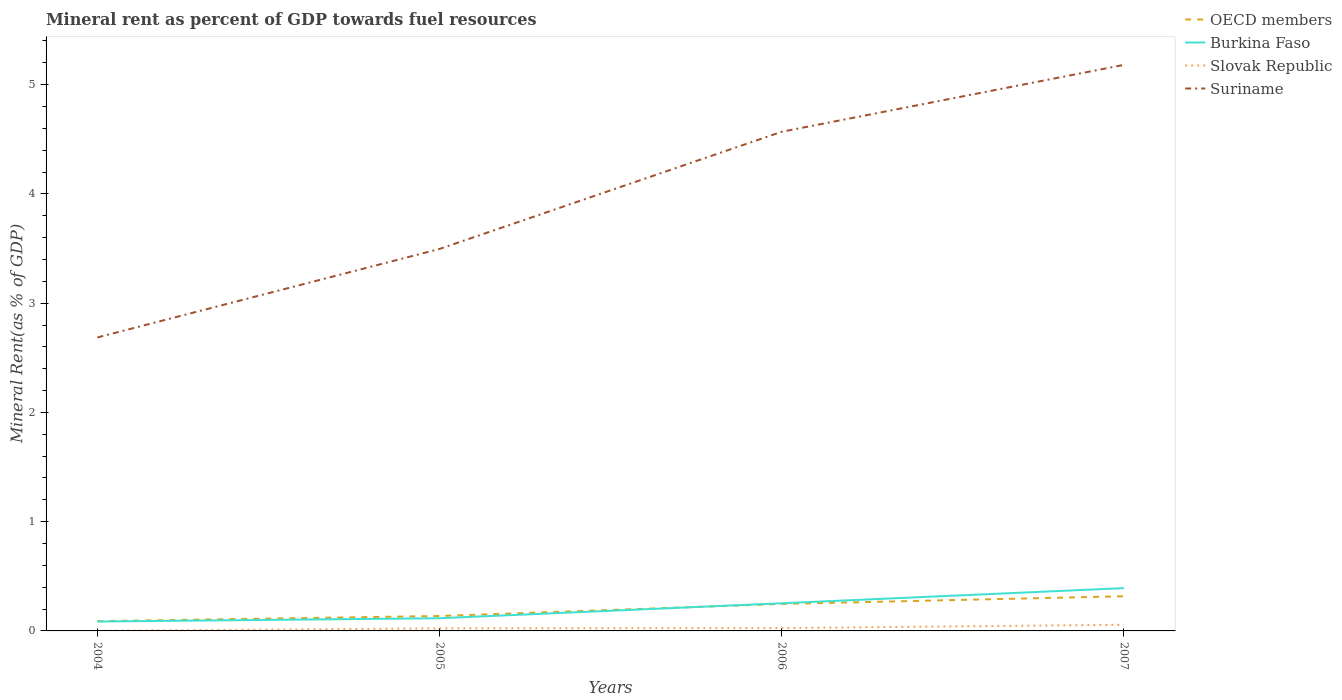Does the line corresponding to Burkina Faso intersect with the line corresponding to OECD members?
Your response must be concise. Yes. Across all years, what is the maximum mineral rent in Slovak Republic?
Your answer should be very brief. 0. What is the total mineral rent in Burkina Faso in the graph?
Make the answer very short. -0.28. What is the difference between the highest and the second highest mineral rent in Burkina Faso?
Provide a succinct answer. 0.31. What is the difference between the highest and the lowest mineral rent in OECD members?
Your response must be concise. 2. How many lines are there?
Ensure brevity in your answer.  4. What is the difference between two consecutive major ticks on the Y-axis?
Offer a terse response. 1. Are the values on the major ticks of Y-axis written in scientific E-notation?
Provide a succinct answer. No. What is the title of the graph?
Provide a succinct answer. Mineral rent as percent of GDP towards fuel resources. What is the label or title of the X-axis?
Make the answer very short. Years. What is the label or title of the Y-axis?
Offer a very short reply. Mineral Rent(as % of GDP). What is the Mineral Rent(as % of GDP) of OECD members in 2004?
Your answer should be very brief. 0.09. What is the Mineral Rent(as % of GDP) of Burkina Faso in 2004?
Ensure brevity in your answer.  0.09. What is the Mineral Rent(as % of GDP) in Slovak Republic in 2004?
Provide a succinct answer. 0. What is the Mineral Rent(as % of GDP) of Suriname in 2004?
Give a very brief answer. 2.69. What is the Mineral Rent(as % of GDP) in OECD members in 2005?
Offer a terse response. 0.14. What is the Mineral Rent(as % of GDP) in Burkina Faso in 2005?
Offer a terse response. 0.12. What is the Mineral Rent(as % of GDP) in Slovak Republic in 2005?
Offer a terse response. 0.02. What is the Mineral Rent(as % of GDP) of Suriname in 2005?
Provide a succinct answer. 3.5. What is the Mineral Rent(as % of GDP) of OECD members in 2006?
Give a very brief answer. 0.25. What is the Mineral Rent(as % of GDP) in Burkina Faso in 2006?
Provide a short and direct response. 0.25. What is the Mineral Rent(as % of GDP) of Slovak Republic in 2006?
Offer a very short reply. 0.03. What is the Mineral Rent(as % of GDP) of Suriname in 2006?
Your answer should be very brief. 4.57. What is the Mineral Rent(as % of GDP) in OECD members in 2007?
Give a very brief answer. 0.32. What is the Mineral Rent(as % of GDP) of Burkina Faso in 2007?
Your answer should be compact. 0.39. What is the Mineral Rent(as % of GDP) of Slovak Republic in 2007?
Make the answer very short. 0.06. What is the Mineral Rent(as % of GDP) of Suriname in 2007?
Your response must be concise. 5.18. Across all years, what is the maximum Mineral Rent(as % of GDP) of OECD members?
Provide a succinct answer. 0.32. Across all years, what is the maximum Mineral Rent(as % of GDP) in Burkina Faso?
Your answer should be compact. 0.39. Across all years, what is the maximum Mineral Rent(as % of GDP) of Slovak Republic?
Give a very brief answer. 0.06. Across all years, what is the maximum Mineral Rent(as % of GDP) in Suriname?
Keep it short and to the point. 5.18. Across all years, what is the minimum Mineral Rent(as % of GDP) of OECD members?
Offer a terse response. 0.09. Across all years, what is the minimum Mineral Rent(as % of GDP) in Burkina Faso?
Your response must be concise. 0.09. Across all years, what is the minimum Mineral Rent(as % of GDP) of Slovak Republic?
Give a very brief answer. 0. Across all years, what is the minimum Mineral Rent(as % of GDP) in Suriname?
Offer a terse response. 2.69. What is the total Mineral Rent(as % of GDP) of OECD members in the graph?
Make the answer very short. 0.79. What is the total Mineral Rent(as % of GDP) in Burkina Faso in the graph?
Provide a succinct answer. 0.85. What is the total Mineral Rent(as % of GDP) in Slovak Republic in the graph?
Keep it short and to the point. 0.11. What is the total Mineral Rent(as % of GDP) of Suriname in the graph?
Give a very brief answer. 15.93. What is the difference between the Mineral Rent(as % of GDP) of OECD members in 2004 and that in 2005?
Offer a very short reply. -0.05. What is the difference between the Mineral Rent(as % of GDP) in Burkina Faso in 2004 and that in 2005?
Your response must be concise. -0.03. What is the difference between the Mineral Rent(as % of GDP) in Slovak Republic in 2004 and that in 2005?
Provide a short and direct response. -0.02. What is the difference between the Mineral Rent(as % of GDP) of Suriname in 2004 and that in 2005?
Provide a short and direct response. -0.81. What is the difference between the Mineral Rent(as % of GDP) in OECD members in 2004 and that in 2006?
Provide a short and direct response. -0.16. What is the difference between the Mineral Rent(as % of GDP) of Burkina Faso in 2004 and that in 2006?
Your answer should be compact. -0.17. What is the difference between the Mineral Rent(as % of GDP) of Slovak Republic in 2004 and that in 2006?
Your response must be concise. -0.02. What is the difference between the Mineral Rent(as % of GDP) in Suriname in 2004 and that in 2006?
Give a very brief answer. -1.88. What is the difference between the Mineral Rent(as % of GDP) of OECD members in 2004 and that in 2007?
Your response must be concise. -0.23. What is the difference between the Mineral Rent(as % of GDP) of Burkina Faso in 2004 and that in 2007?
Provide a short and direct response. -0.31. What is the difference between the Mineral Rent(as % of GDP) in Slovak Republic in 2004 and that in 2007?
Your answer should be very brief. -0.06. What is the difference between the Mineral Rent(as % of GDP) in Suriname in 2004 and that in 2007?
Your response must be concise. -2.49. What is the difference between the Mineral Rent(as % of GDP) of OECD members in 2005 and that in 2006?
Provide a succinct answer. -0.11. What is the difference between the Mineral Rent(as % of GDP) in Burkina Faso in 2005 and that in 2006?
Offer a very short reply. -0.14. What is the difference between the Mineral Rent(as % of GDP) of Slovak Republic in 2005 and that in 2006?
Make the answer very short. -0. What is the difference between the Mineral Rent(as % of GDP) in Suriname in 2005 and that in 2006?
Your answer should be compact. -1.07. What is the difference between the Mineral Rent(as % of GDP) of OECD members in 2005 and that in 2007?
Make the answer very short. -0.18. What is the difference between the Mineral Rent(as % of GDP) of Burkina Faso in 2005 and that in 2007?
Your answer should be compact. -0.28. What is the difference between the Mineral Rent(as % of GDP) of Slovak Republic in 2005 and that in 2007?
Your answer should be very brief. -0.03. What is the difference between the Mineral Rent(as % of GDP) in Suriname in 2005 and that in 2007?
Make the answer very short. -1.69. What is the difference between the Mineral Rent(as % of GDP) in OECD members in 2006 and that in 2007?
Your answer should be compact. -0.07. What is the difference between the Mineral Rent(as % of GDP) in Burkina Faso in 2006 and that in 2007?
Your response must be concise. -0.14. What is the difference between the Mineral Rent(as % of GDP) of Slovak Republic in 2006 and that in 2007?
Provide a succinct answer. -0.03. What is the difference between the Mineral Rent(as % of GDP) in Suriname in 2006 and that in 2007?
Your answer should be very brief. -0.61. What is the difference between the Mineral Rent(as % of GDP) in OECD members in 2004 and the Mineral Rent(as % of GDP) in Burkina Faso in 2005?
Offer a very short reply. -0.03. What is the difference between the Mineral Rent(as % of GDP) in OECD members in 2004 and the Mineral Rent(as % of GDP) in Slovak Republic in 2005?
Ensure brevity in your answer.  0.07. What is the difference between the Mineral Rent(as % of GDP) in OECD members in 2004 and the Mineral Rent(as % of GDP) in Suriname in 2005?
Offer a very short reply. -3.41. What is the difference between the Mineral Rent(as % of GDP) of Burkina Faso in 2004 and the Mineral Rent(as % of GDP) of Slovak Republic in 2005?
Your answer should be compact. 0.06. What is the difference between the Mineral Rent(as % of GDP) in Burkina Faso in 2004 and the Mineral Rent(as % of GDP) in Suriname in 2005?
Provide a short and direct response. -3.41. What is the difference between the Mineral Rent(as % of GDP) of Slovak Republic in 2004 and the Mineral Rent(as % of GDP) of Suriname in 2005?
Your response must be concise. -3.49. What is the difference between the Mineral Rent(as % of GDP) of OECD members in 2004 and the Mineral Rent(as % of GDP) of Burkina Faso in 2006?
Your answer should be compact. -0.16. What is the difference between the Mineral Rent(as % of GDP) in OECD members in 2004 and the Mineral Rent(as % of GDP) in Slovak Republic in 2006?
Offer a terse response. 0.06. What is the difference between the Mineral Rent(as % of GDP) of OECD members in 2004 and the Mineral Rent(as % of GDP) of Suriname in 2006?
Your answer should be very brief. -4.48. What is the difference between the Mineral Rent(as % of GDP) in Burkina Faso in 2004 and the Mineral Rent(as % of GDP) in Slovak Republic in 2006?
Offer a terse response. 0.06. What is the difference between the Mineral Rent(as % of GDP) of Burkina Faso in 2004 and the Mineral Rent(as % of GDP) of Suriname in 2006?
Your answer should be very brief. -4.48. What is the difference between the Mineral Rent(as % of GDP) of Slovak Republic in 2004 and the Mineral Rent(as % of GDP) of Suriname in 2006?
Offer a very short reply. -4.57. What is the difference between the Mineral Rent(as % of GDP) of OECD members in 2004 and the Mineral Rent(as % of GDP) of Burkina Faso in 2007?
Your answer should be very brief. -0.3. What is the difference between the Mineral Rent(as % of GDP) in OECD members in 2004 and the Mineral Rent(as % of GDP) in Slovak Republic in 2007?
Your answer should be very brief. 0.03. What is the difference between the Mineral Rent(as % of GDP) in OECD members in 2004 and the Mineral Rent(as % of GDP) in Suriname in 2007?
Give a very brief answer. -5.09. What is the difference between the Mineral Rent(as % of GDP) of Burkina Faso in 2004 and the Mineral Rent(as % of GDP) of Slovak Republic in 2007?
Ensure brevity in your answer.  0.03. What is the difference between the Mineral Rent(as % of GDP) of Burkina Faso in 2004 and the Mineral Rent(as % of GDP) of Suriname in 2007?
Provide a succinct answer. -5.1. What is the difference between the Mineral Rent(as % of GDP) in Slovak Republic in 2004 and the Mineral Rent(as % of GDP) in Suriname in 2007?
Offer a very short reply. -5.18. What is the difference between the Mineral Rent(as % of GDP) in OECD members in 2005 and the Mineral Rent(as % of GDP) in Burkina Faso in 2006?
Your answer should be very brief. -0.12. What is the difference between the Mineral Rent(as % of GDP) of OECD members in 2005 and the Mineral Rent(as % of GDP) of Slovak Republic in 2006?
Provide a short and direct response. 0.11. What is the difference between the Mineral Rent(as % of GDP) in OECD members in 2005 and the Mineral Rent(as % of GDP) in Suriname in 2006?
Keep it short and to the point. -4.43. What is the difference between the Mineral Rent(as % of GDP) of Burkina Faso in 2005 and the Mineral Rent(as % of GDP) of Slovak Republic in 2006?
Offer a terse response. 0.09. What is the difference between the Mineral Rent(as % of GDP) of Burkina Faso in 2005 and the Mineral Rent(as % of GDP) of Suriname in 2006?
Your answer should be very brief. -4.45. What is the difference between the Mineral Rent(as % of GDP) of Slovak Republic in 2005 and the Mineral Rent(as % of GDP) of Suriname in 2006?
Offer a terse response. -4.55. What is the difference between the Mineral Rent(as % of GDP) of OECD members in 2005 and the Mineral Rent(as % of GDP) of Burkina Faso in 2007?
Ensure brevity in your answer.  -0.26. What is the difference between the Mineral Rent(as % of GDP) of OECD members in 2005 and the Mineral Rent(as % of GDP) of Slovak Republic in 2007?
Offer a terse response. 0.08. What is the difference between the Mineral Rent(as % of GDP) in OECD members in 2005 and the Mineral Rent(as % of GDP) in Suriname in 2007?
Make the answer very short. -5.04. What is the difference between the Mineral Rent(as % of GDP) of Burkina Faso in 2005 and the Mineral Rent(as % of GDP) of Slovak Republic in 2007?
Give a very brief answer. 0.06. What is the difference between the Mineral Rent(as % of GDP) of Burkina Faso in 2005 and the Mineral Rent(as % of GDP) of Suriname in 2007?
Your answer should be very brief. -5.07. What is the difference between the Mineral Rent(as % of GDP) in Slovak Republic in 2005 and the Mineral Rent(as % of GDP) in Suriname in 2007?
Provide a short and direct response. -5.16. What is the difference between the Mineral Rent(as % of GDP) of OECD members in 2006 and the Mineral Rent(as % of GDP) of Burkina Faso in 2007?
Give a very brief answer. -0.14. What is the difference between the Mineral Rent(as % of GDP) in OECD members in 2006 and the Mineral Rent(as % of GDP) in Slovak Republic in 2007?
Your answer should be very brief. 0.19. What is the difference between the Mineral Rent(as % of GDP) of OECD members in 2006 and the Mineral Rent(as % of GDP) of Suriname in 2007?
Make the answer very short. -4.93. What is the difference between the Mineral Rent(as % of GDP) in Burkina Faso in 2006 and the Mineral Rent(as % of GDP) in Slovak Republic in 2007?
Keep it short and to the point. 0.2. What is the difference between the Mineral Rent(as % of GDP) in Burkina Faso in 2006 and the Mineral Rent(as % of GDP) in Suriname in 2007?
Make the answer very short. -4.93. What is the difference between the Mineral Rent(as % of GDP) of Slovak Republic in 2006 and the Mineral Rent(as % of GDP) of Suriname in 2007?
Offer a terse response. -5.16. What is the average Mineral Rent(as % of GDP) in OECD members per year?
Ensure brevity in your answer.  0.2. What is the average Mineral Rent(as % of GDP) in Burkina Faso per year?
Keep it short and to the point. 0.21. What is the average Mineral Rent(as % of GDP) of Slovak Republic per year?
Make the answer very short. 0.03. What is the average Mineral Rent(as % of GDP) in Suriname per year?
Your answer should be compact. 3.98. In the year 2004, what is the difference between the Mineral Rent(as % of GDP) of OECD members and Mineral Rent(as % of GDP) of Burkina Faso?
Your response must be concise. 0. In the year 2004, what is the difference between the Mineral Rent(as % of GDP) of OECD members and Mineral Rent(as % of GDP) of Slovak Republic?
Your response must be concise. 0.09. In the year 2004, what is the difference between the Mineral Rent(as % of GDP) in OECD members and Mineral Rent(as % of GDP) in Suriname?
Your answer should be compact. -2.6. In the year 2004, what is the difference between the Mineral Rent(as % of GDP) in Burkina Faso and Mineral Rent(as % of GDP) in Slovak Republic?
Your response must be concise. 0.08. In the year 2004, what is the difference between the Mineral Rent(as % of GDP) in Burkina Faso and Mineral Rent(as % of GDP) in Suriname?
Your response must be concise. -2.6. In the year 2004, what is the difference between the Mineral Rent(as % of GDP) in Slovak Republic and Mineral Rent(as % of GDP) in Suriname?
Keep it short and to the point. -2.68. In the year 2005, what is the difference between the Mineral Rent(as % of GDP) of OECD members and Mineral Rent(as % of GDP) of Burkina Faso?
Your answer should be very brief. 0.02. In the year 2005, what is the difference between the Mineral Rent(as % of GDP) of OECD members and Mineral Rent(as % of GDP) of Slovak Republic?
Provide a succinct answer. 0.11. In the year 2005, what is the difference between the Mineral Rent(as % of GDP) of OECD members and Mineral Rent(as % of GDP) of Suriname?
Your response must be concise. -3.36. In the year 2005, what is the difference between the Mineral Rent(as % of GDP) of Burkina Faso and Mineral Rent(as % of GDP) of Slovak Republic?
Provide a short and direct response. 0.09. In the year 2005, what is the difference between the Mineral Rent(as % of GDP) in Burkina Faso and Mineral Rent(as % of GDP) in Suriname?
Keep it short and to the point. -3.38. In the year 2005, what is the difference between the Mineral Rent(as % of GDP) in Slovak Republic and Mineral Rent(as % of GDP) in Suriname?
Keep it short and to the point. -3.47. In the year 2006, what is the difference between the Mineral Rent(as % of GDP) in OECD members and Mineral Rent(as % of GDP) in Burkina Faso?
Ensure brevity in your answer.  -0.01. In the year 2006, what is the difference between the Mineral Rent(as % of GDP) in OECD members and Mineral Rent(as % of GDP) in Slovak Republic?
Give a very brief answer. 0.22. In the year 2006, what is the difference between the Mineral Rent(as % of GDP) in OECD members and Mineral Rent(as % of GDP) in Suriname?
Offer a very short reply. -4.32. In the year 2006, what is the difference between the Mineral Rent(as % of GDP) of Burkina Faso and Mineral Rent(as % of GDP) of Slovak Republic?
Your answer should be compact. 0.23. In the year 2006, what is the difference between the Mineral Rent(as % of GDP) of Burkina Faso and Mineral Rent(as % of GDP) of Suriname?
Offer a terse response. -4.32. In the year 2006, what is the difference between the Mineral Rent(as % of GDP) in Slovak Republic and Mineral Rent(as % of GDP) in Suriname?
Make the answer very short. -4.54. In the year 2007, what is the difference between the Mineral Rent(as % of GDP) in OECD members and Mineral Rent(as % of GDP) in Burkina Faso?
Give a very brief answer. -0.07. In the year 2007, what is the difference between the Mineral Rent(as % of GDP) of OECD members and Mineral Rent(as % of GDP) of Slovak Republic?
Make the answer very short. 0.26. In the year 2007, what is the difference between the Mineral Rent(as % of GDP) of OECD members and Mineral Rent(as % of GDP) of Suriname?
Offer a very short reply. -4.86. In the year 2007, what is the difference between the Mineral Rent(as % of GDP) in Burkina Faso and Mineral Rent(as % of GDP) in Slovak Republic?
Offer a terse response. 0.34. In the year 2007, what is the difference between the Mineral Rent(as % of GDP) in Burkina Faso and Mineral Rent(as % of GDP) in Suriname?
Provide a succinct answer. -4.79. In the year 2007, what is the difference between the Mineral Rent(as % of GDP) of Slovak Republic and Mineral Rent(as % of GDP) of Suriname?
Keep it short and to the point. -5.12. What is the ratio of the Mineral Rent(as % of GDP) in OECD members in 2004 to that in 2005?
Your response must be concise. 0.65. What is the ratio of the Mineral Rent(as % of GDP) of Burkina Faso in 2004 to that in 2005?
Offer a very short reply. 0.74. What is the ratio of the Mineral Rent(as % of GDP) of Slovak Republic in 2004 to that in 2005?
Ensure brevity in your answer.  0.06. What is the ratio of the Mineral Rent(as % of GDP) in Suriname in 2004 to that in 2005?
Your answer should be compact. 0.77. What is the ratio of the Mineral Rent(as % of GDP) of OECD members in 2004 to that in 2006?
Provide a short and direct response. 0.36. What is the ratio of the Mineral Rent(as % of GDP) in Burkina Faso in 2004 to that in 2006?
Ensure brevity in your answer.  0.34. What is the ratio of the Mineral Rent(as % of GDP) of Slovak Republic in 2004 to that in 2006?
Keep it short and to the point. 0.06. What is the ratio of the Mineral Rent(as % of GDP) of Suriname in 2004 to that in 2006?
Provide a succinct answer. 0.59. What is the ratio of the Mineral Rent(as % of GDP) in OECD members in 2004 to that in 2007?
Keep it short and to the point. 0.28. What is the ratio of the Mineral Rent(as % of GDP) in Burkina Faso in 2004 to that in 2007?
Provide a short and direct response. 0.22. What is the ratio of the Mineral Rent(as % of GDP) in Slovak Republic in 2004 to that in 2007?
Your answer should be very brief. 0.03. What is the ratio of the Mineral Rent(as % of GDP) of Suriname in 2004 to that in 2007?
Your answer should be very brief. 0.52. What is the ratio of the Mineral Rent(as % of GDP) of OECD members in 2005 to that in 2006?
Provide a succinct answer. 0.55. What is the ratio of the Mineral Rent(as % of GDP) of Burkina Faso in 2005 to that in 2006?
Your answer should be compact. 0.46. What is the ratio of the Mineral Rent(as % of GDP) of Slovak Republic in 2005 to that in 2006?
Your response must be concise. 0.9. What is the ratio of the Mineral Rent(as % of GDP) in Suriname in 2005 to that in 2006?
Make the answer very short. 0.77. What is the ratio of the Mineral Rent(as % of GDP) of OECD members in 2005 to that in 2007?
Offer a very short reply. 0.43. What is the ratio of the Mineral Rent(as % of GDP) of Burkina Faso in 2005 to that in 2007?
Make the answer very short. 0.3. What is the ratio of the Mineral Rent(as % of GDP) of Slovak Republic in 2005 to that in 2007?
Ensure brevity in your answer.  0.42. What is the ratio of the Mineral Rent(as % of GDP) of Suriname in 2005 to that in 2007?
Provide a short and direct response. 0.67. What is the ratio of the Mineral Rent(as % of GDP) of OECD members in 2006 to that in 2007?
Your answer should be very brief. 0.78. What is the ratio of the Mineral Rent(as % of GDP) in Burkina Faso in 2006 to that in 2007?
Your answer should be very brief. 0.65. What is the ratio of the Mineral Rent(as % of GDP) in Slovak Republic in 2006 to that in 2007?
Provide a succinct answer. 0.46. What is the ratio of the Mineral Rent(as % of GDP) in Suriname in 2006 to that in 2007?
Your answer should be compact. 0.88. What is the difference between the highest and the second highest Mineral Rent(as % of GDP) in OECD members?
Provide a succinct answer. 0.07. What is the difference between the highest and the second highest Mineral Rent(as % of GDP) in Burkina Faso?
Your answer should be very brief. 0.14. What is the difference between the highest and the second highest Mineral Rent(as % of GDP) of Slovak Republic?
Make the answer very short. 0.03. What is the difference between the highest and the second highest Mineral Rent(as % of GDP) in Suriname?
Make the answer very short. 0.61. What is the difference between the highest and the lowest Mineral Rent(as % of GDP) in OECD members?
Provide a short and direct response. 0.23. What is the difference between the highest and the lowest Mineral Rent(as % of GDP) in Burkina Faso?
Provide a short and direct response. 0.31. What is the difference between the highest and the lowest Mineral Rent(as % of GDP) of Slovak Republic?
Offer a terse response. 0.06. What is the difference between the highest and the lowest Mineral Rent(as % of GDP) of Suriname?
Provide a succinct answer. 2.49. 